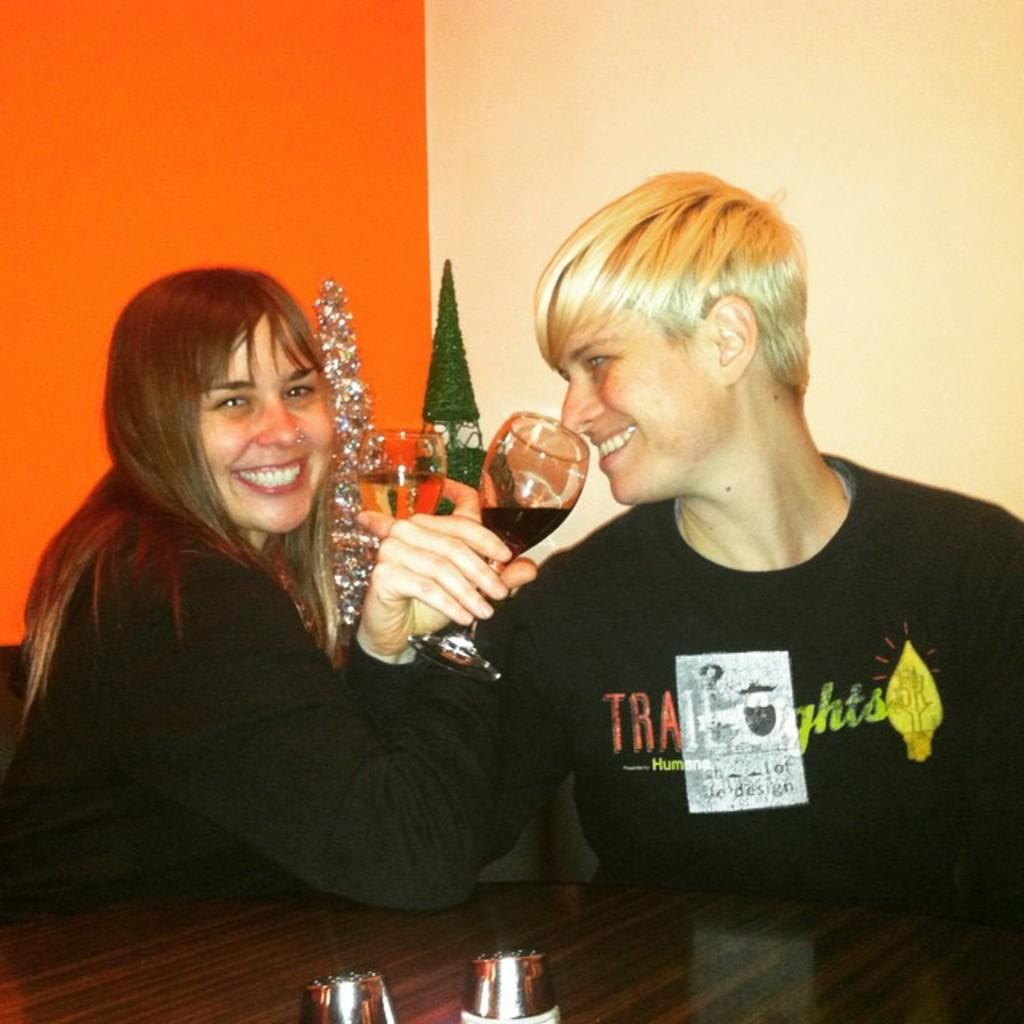How many people are present in the image? There are two people in the image, a woman and a man. What are the expressions on their faces? Both the woman and the man are smiling in the image. What are they holding in their hands? They are holding a glass in their hands. What can be seen in the background of the image? There is a wall in the background of the image. What is another object present in the image? There is a table in the image. What type of pen is the woman using to write a suggestion on the table? There is no pen or suggestion visible in the image; the woman and the man are simply holding glasses and smiling. 